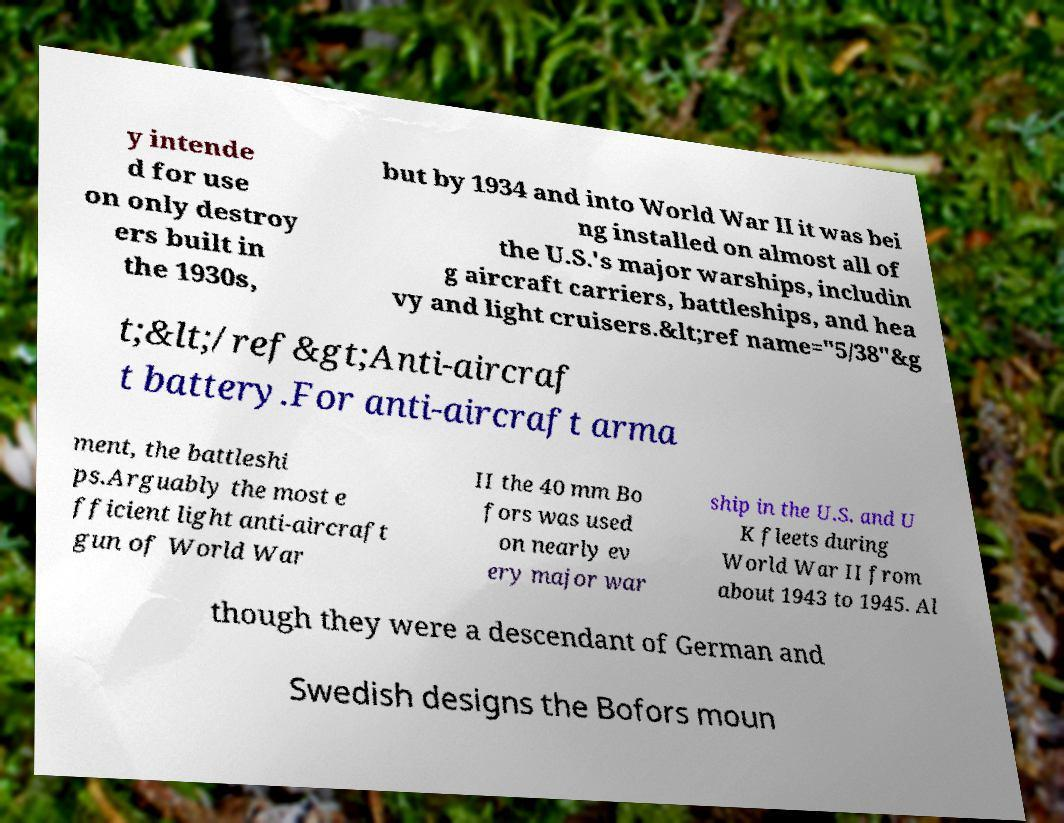What messages or text are displayed in this image? I need them in a readable, typed format. y intende d for use on only destroy ers built in the 1930s, but by 1934 and into World War II it was bei ng installed on almost all of the U.S.'s major warships, includin g aircraft carriers, battleships, and hea vy and light cruisers.&lt;ref name="5/38"&g t;&lt;/ref&gt;Anti-aircraf t battery.For anti-aircraft arma ment, the battleshi ps.Arguably the most e fficient light anti-aircraft gun of World War II the 40 mm Bo fors was used on nearly ev ery major war ship in the U.S. and U K fleets during World War II from about 1943 to 1945. Al though they were a descendant of German and Swedish designs the Bofors moun 